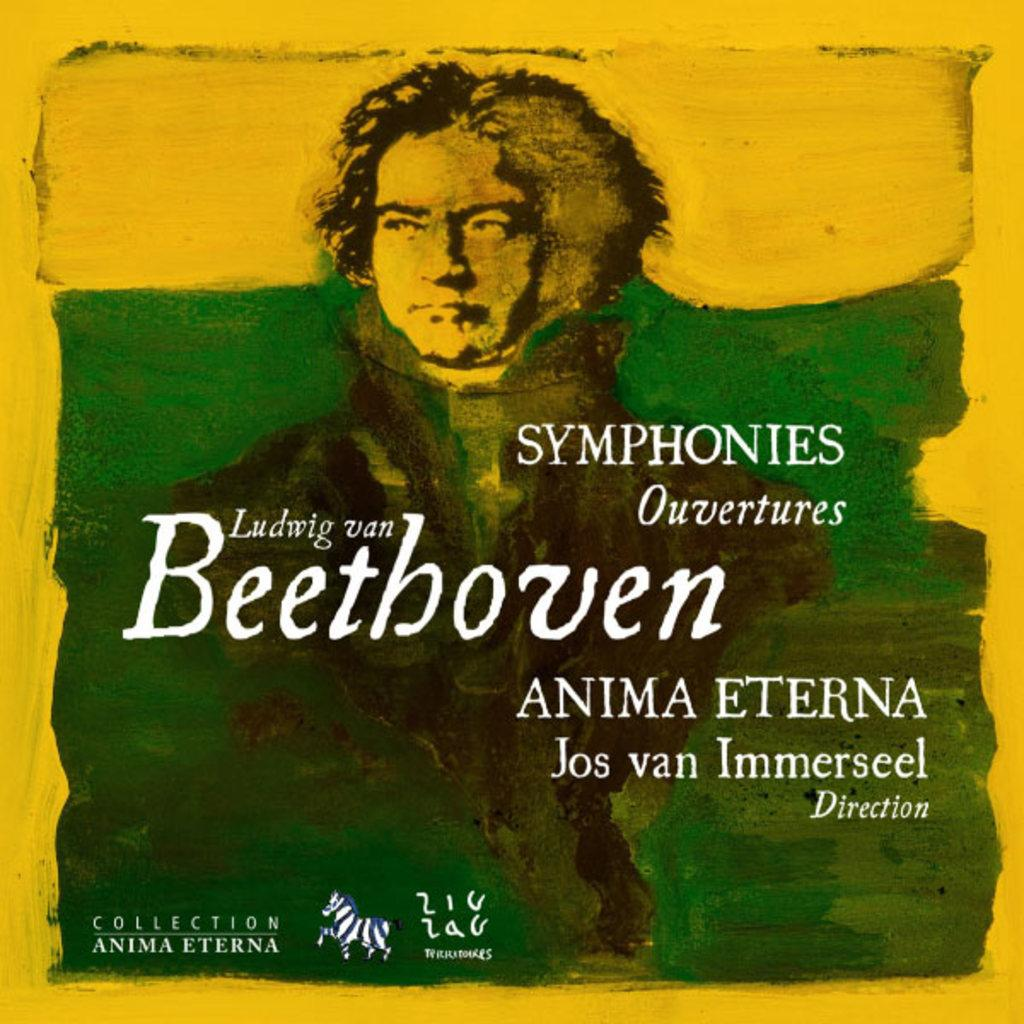What is featured on the poster in the image? The poster contains a painting of a person. Are there any words or phrases on the poster? Yes, there are texts on the poster. What additional feature can be seen on the poster? There is a watermark on the poster. What color is the background of the poster? The background of the poster is yellow in color. What type of skin is visible on the plough in the image? There is no plough present in the image; it features a poster with a painting of a person. How much dirt can be seen on the person's shoes in the image? The image does not show the person's shoes, so it is not possible to determine the amount of dirt on them. 